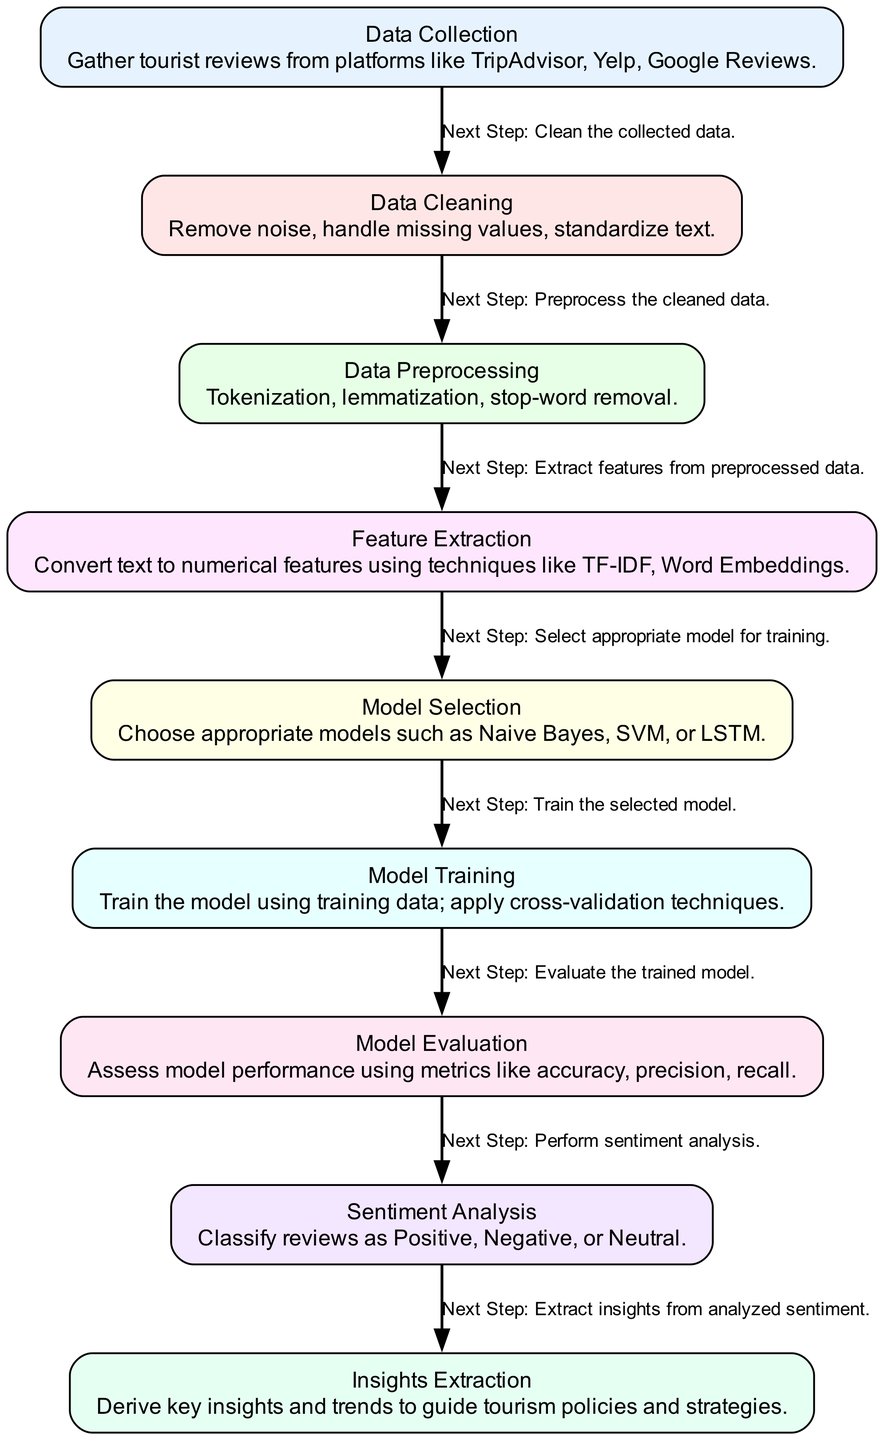What is the first step in the diagram? The diagram begins with the "Data Collection" node, which represents the initial phase of gathering tourist reviews from various platforms.
Answer: Data Collection How many nodes are present in the diagram? The diagram consists of eight distinct nodes that represent different stages in the sentiment analysis process.
Answer: Eight What is the relationship between "Model Training" and "Model Evaluation"? The edge from "Model Training" to "Model Evaluation" indicates that after training the model, the next logical step is to evaluate its performance.
Answer: Next Step: Evaluate the trained model Which step comes after "Feature Extraction"? The diagram shows that following "Feature Extraction," the next step is "Model Selection," where the appropriate models are chosen for training.
Answer: Model Selection What type of analysis is performed after "Model Evaluation"? Once the model has been evaluated, the subsequent analysis conducted is the "Sentiment Analysis," where reviews are classified into categories such as Positive, Negative, or Neutral.
Answer: Sentiment Analysis How does "Insights Extraction" relate to "Sentiment Analysis"? The edge indicates that after classifying the reviews in the sentiment analysis stage, the next action is "Insights Extraction" to derive key insights and trends from the analyzed sentiment.
Answer: Next Step: Extract insights from analyzed sentiment What method of text feature conversion is mentioned in the diagram? The "Feature Extraction" node specifies techniques like TF-IDF and Word Embeddings to convert text into numerical features for analysis.
Answer: TF-IDF, Word Embeddings Which node processes the cleaned data? The "Data Preprocessing" node is responsible for handling and preparing the data after it has been cleaned in the previous step.
Answer: Data Preprocessing 